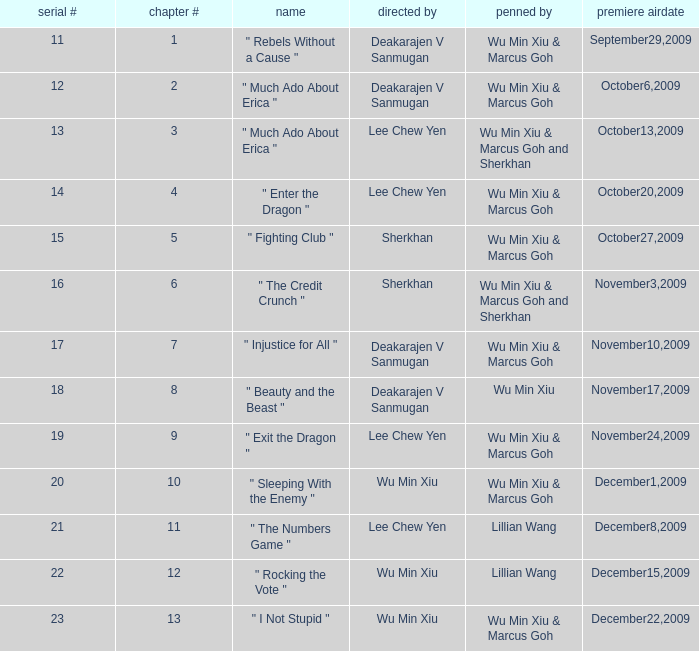What is the episode number for series 17? 7.0. 